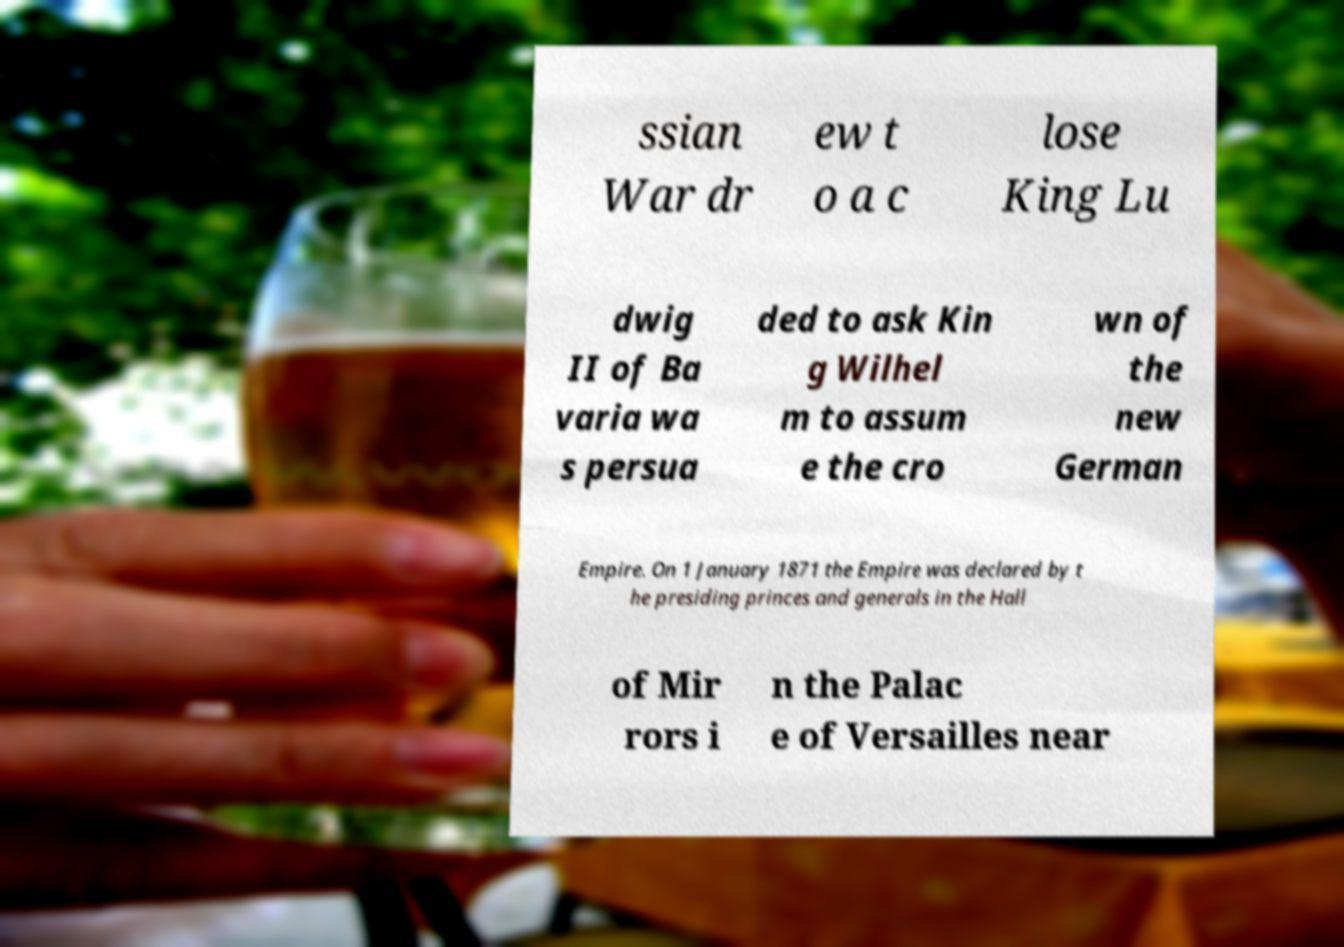Can you accurately transcribe the text from the provided image for me? ssian War dr ew t o a c lose King Lu dwig II of Ba varia wa s persua ded to ask Kin g Wilhel m to assum e the cro wn of the new German Empire. On 1 January 1871 the Empire was declared by t he presiding princes and generals in the Hall of Mir rors i n the Palac e of Versailles near 